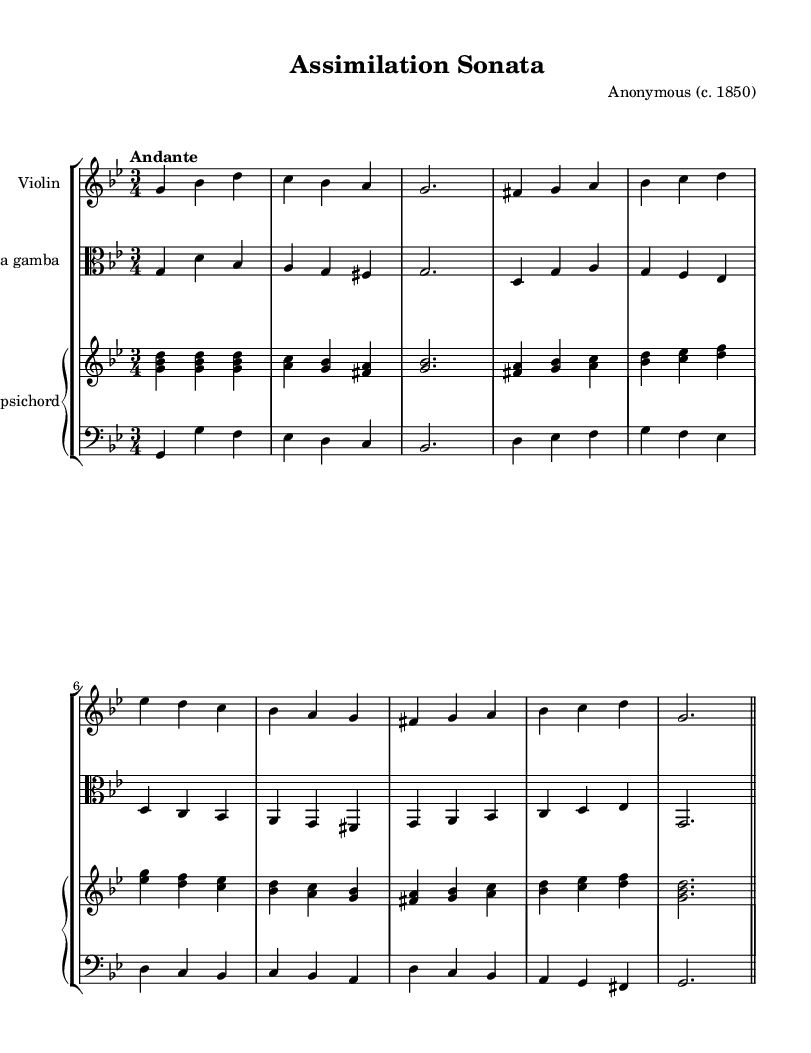What is the key signature of this music? The key signature shows two flats, which indicates the piece is in G minor.
Answer: G minor What is the time signature of this music? The time signature is 3/4, indicating that there are three beats per measure, and each quarter note receives one beat.
Answer: 3/4 What is the tempo marking for this piece? The tempo marking is "Andante," which indicates a moderate walking pace.
Answer: Andante How many parts are there in the score? The score features four parts: Violin, Viola da gamba, Harpsichord right hand, and Harpsichord left hand.
Answer: Four In which historical context is this piece likely situated? This piece reflects the Baroque style which was prominent in the 17th and 18th centuries, often characterized by ornamentation and complexity; reflecting cultural assimilation in 19th-century America signifies its adaptation by immigrants.
Answer: Baroque What is the time signature's significance in relation to Baroque music? The 3/4 time signature is common in Baroque dances, allowing for rhythmic fluidity and grace, typical of the era.
Answer: 3/4 What instruments are featured in this chamber music? The instruments are Violin, Viola da gamba, and Harpsichord. These instruments were widely used during the Baroque period.
Answer: Violin, Viola da gamba, Harpsichord 